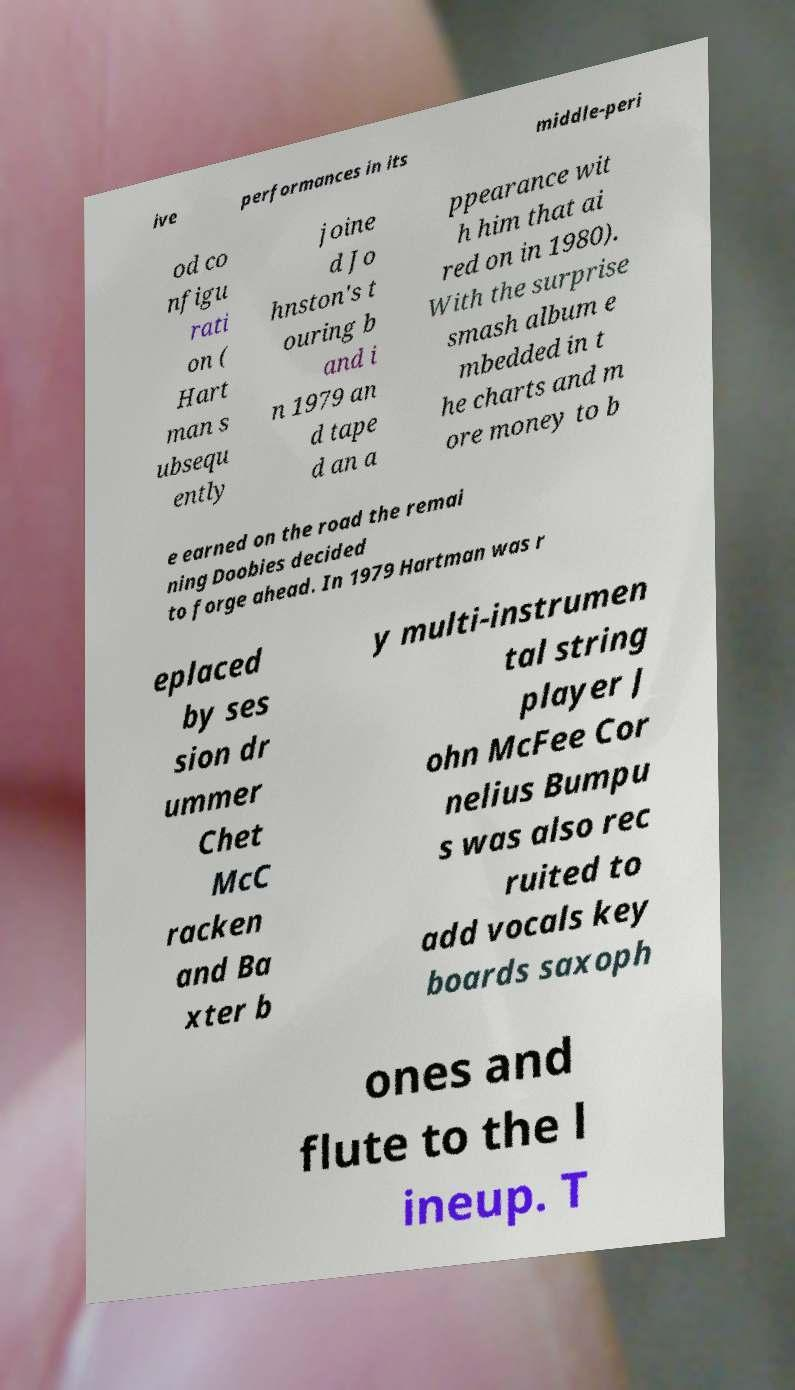Could you extract and type out the text from this image? ive performances in its middle-peri od co nfigu rati on ( Hart man s ubsequ ently joine d Jo hnston's t ouring b and i n 1979 an d tape d an a ppearance wit h him that ai red on in 1980). With the surprise smash album e mbedded in t he charts and m ore money to b e earned on the road the remai ning Doobies decided to forge ahead. In 1979 Hartman was r eplaced by ses sion dr ummer Chet McC racken and Ba xter b y multi-instrumen tal string player J ohn McFee Cor nelius Bumpu s was also rec ruited to add vocals key boards saxoph ones and flute to the l ineup. T 